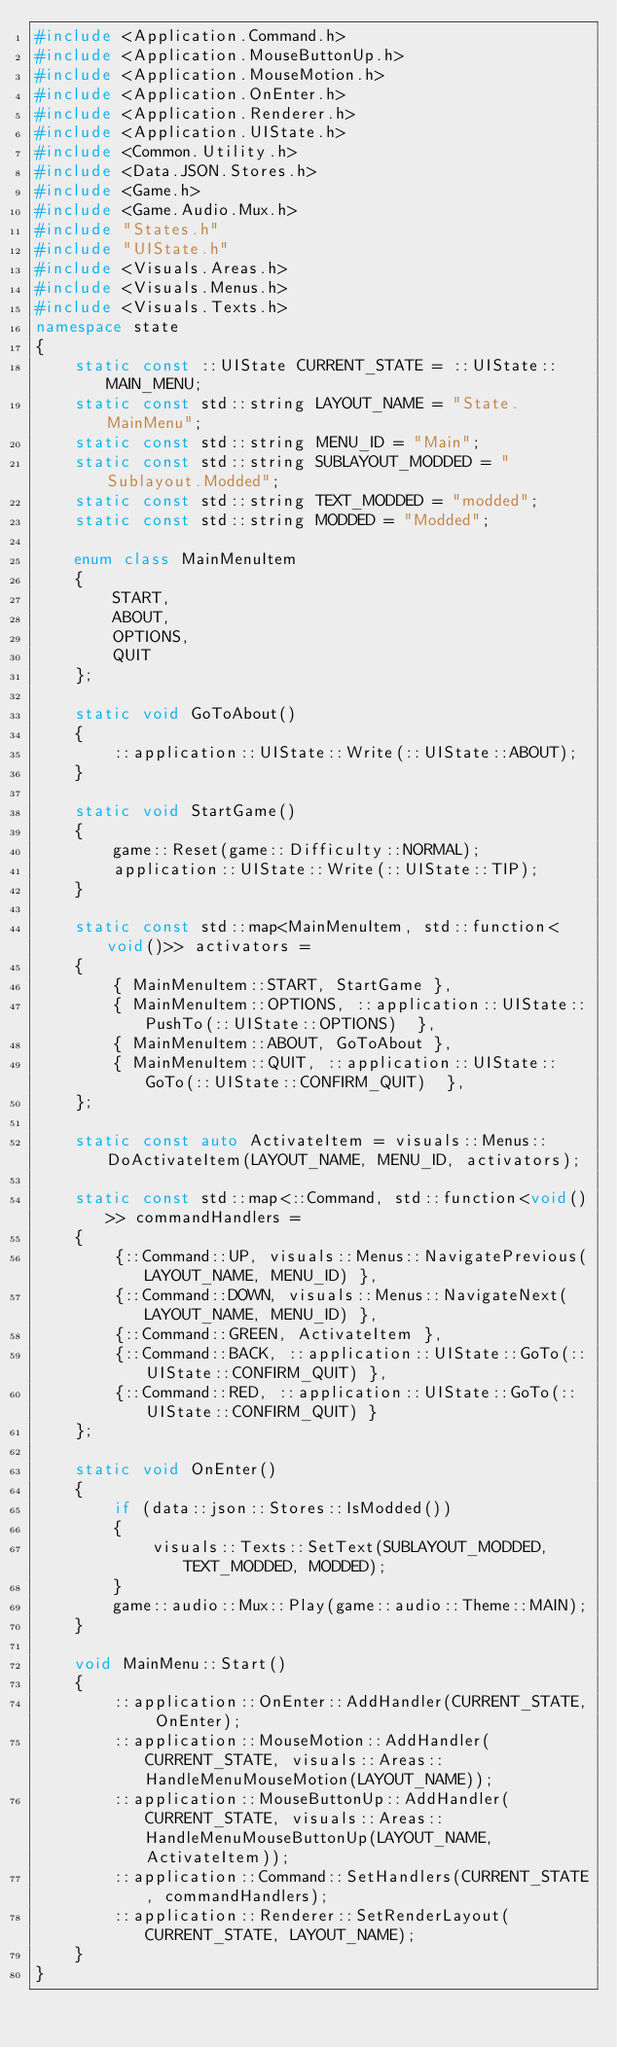Convert code to text. <code><loc_0><loc_0><loc_500><loc_500><_C++_>#include <Application.Command.h>
#include <Application.MouseButtonUp.h>
#include <Application.MouseMotion.h>
#include <Application.OnEnter.h>
#include <Application.Renderer.h>
#include <Application.UIState.h>
#include <Common.Utility.h>
#include <Data.JSON.Stores.h>
#include <Game.h>
#include <Game.Audio.Mux.h>
#include "States.h"
#include "UIState.h"
#include <Visuals.Areas.h>
#include <Visuals.Menus.h>
#include <Visuals.Texts.h>
namespace state
{
	static const ::UIState CURRENT_STATE = ::UIState::MAIN_MENU;
	static const std::string LAYOUT_NAME = "State.MainMenu";
	static const std::string MENU_ID = "Main";
	static const std::string SUBLAYOUT_MODDED = "Sublayout.Modded";
	static const std::string TEXT_MODDED = "modded";
	static const std::string MODDED = "Modded";

	enum class MainMenuItem
	{
		START,
		ABOUT,
		OPTIONS,
		QUIT
	};

	static void GoToAbout()
	{
		::application::UIState::Write(::UIState::ABOUT);
	}

	static void StartGame()
	{
		game::Reset(game::Difficulty::NORMAL);
		application::UIState::Write(::UIState::TIP);
	}

	static const std::map<MainMenuItem, std::function<void()>> activators =
	{
		{ MainMenuItem::START, StartGame },
		{ MainMenuItem::OPTIONS, ::application::UIState::PushTo(::UIState::OPTIONS)  },
		{ MainMenuItem::ABOUT, GoToAbout },
		{ MainMenuItem::QUIT, ::application::UIState::GoTo(::UIState::CONFIRM_QUIT)  },
	};

	static const auto ActivateItem = visuals::Menus::DoActivateItem(LAYOUT_NAME, MENU_ID, activators);

	static const std::map<::Command, std::function<void()>> commandHandlers =
	{
		{::Command::UP, visuals::Menus::NavigatePrevious(LAYOUT_NAME, MENU_ID) },
		{::Command::DOWN, visuals::Menus::NavigateNext(LAYOUT_NAME, MENU_ID) },
		{::Command::GREEN, ActivateItem },
		{::Command::BACK, ::application::UIState::GoTo(::UIState::CONFIRM_QUIT) },
		{::Command::RED, ::application::UIState::GoTo(::UIState::CONFIRM_QUIT) }
	};

	static void OnEnter()
	{
		if (data::json::Stores::IsModded())
		{
			visuals::Texts::SetText(SUBLAYOUT_MODDED, TEXT_MODDED, MODDED);
		}
		game::audio::Mux::Play(game::audio::Theme::MAIN);
	}

	void MainMenu::Start()
	{
		::application::OnEnter::AddHandler(CURRENT_STATE, OnEnter);
		::application::MouseMotion::AddHandler(CURRENT_STATE, visuals::Areas::HandleMenuMouseMotion(LAYOUT_NAME));
		::application::MouseButtonUp::AddHandler(CURRENT_STATE, visuals::Areas::HandleMenuMouseButtonUp(LAYOUT_NAME, ActivateItem));
		::application::Command::SetHandlers(CURRENT_STATE, commandHandlers);
		::application::Renderer::SetRenderLayout(CURRENT_STATE, LAYOUT_NAME);
	}
}</code> 